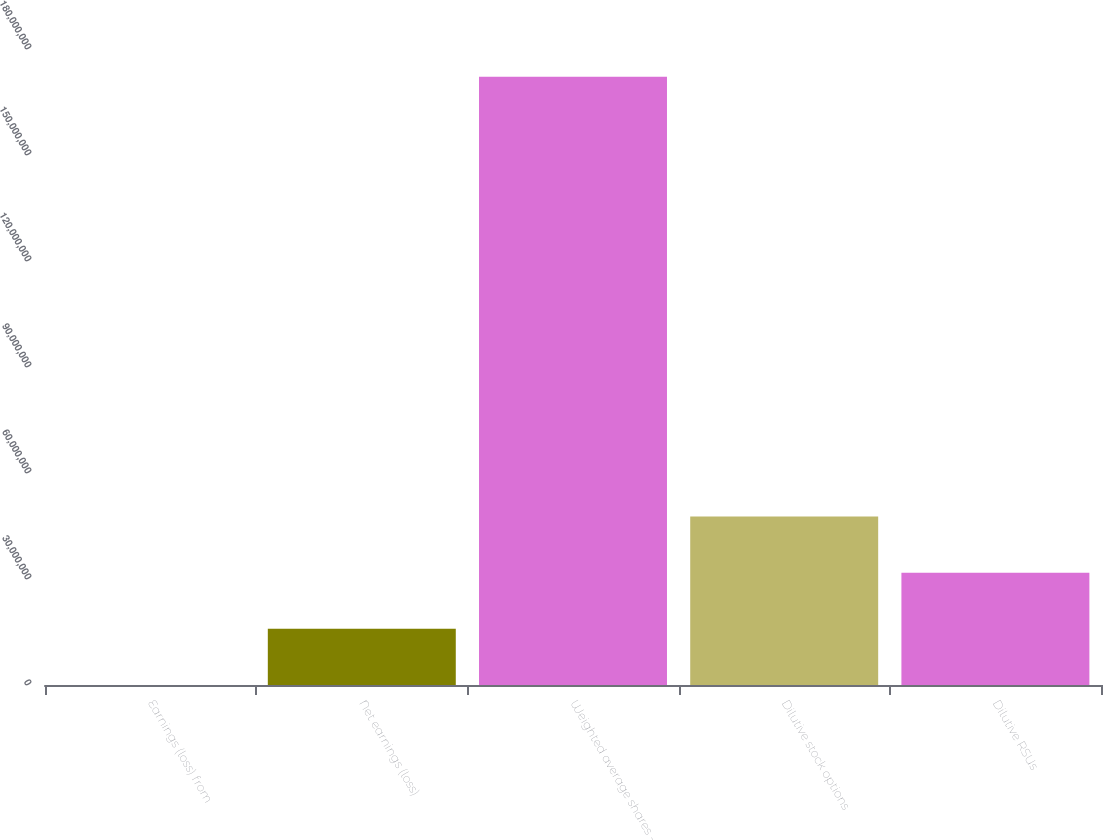Convert chart to OTSL. <chart><loc_0><loc_0><loc_500><loc_500><bar_chart><fcel>Earnings (loss) from<fcel>Net earnings (loss)<fcel>Weighted average shares -<fcel>Dilutive stock options<fcel>Dilutive RSUs<nl><fcel>426<fcel>1.58974e+07<fcel>1.72124e+08<fcel>4.76914e+07<fcel>3.17944e+07<nl></chart> 